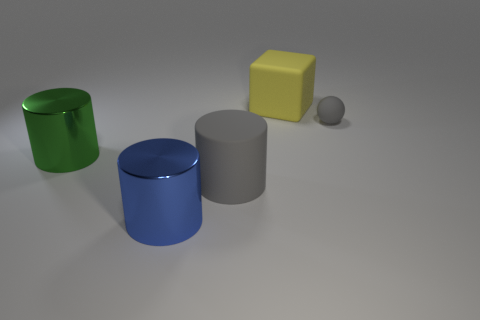Can you describe the lighting and shadows in the scene? The scene is lit from above, producing soft shadows that extend to the right of the objects. The shadows are subtly blurred at the edges, indicating a diffused light source, which contributes to the overall calm and balanced composition of the image. 